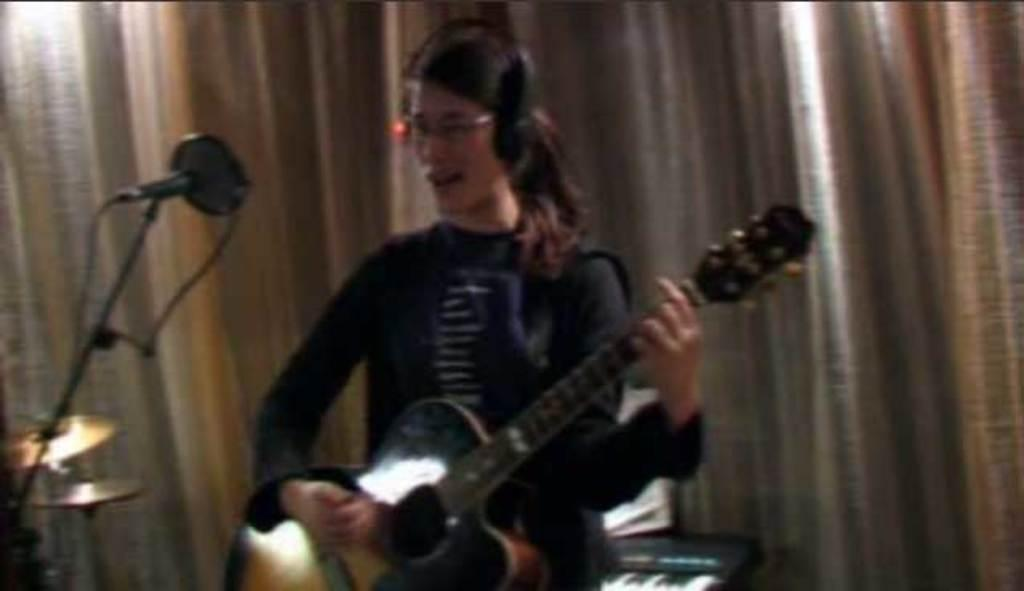Who is the main subject in the image? There is a lady in the picture. What is the lady doing in the image? The lady is sitting on a table. What is the lady wearing in the image? The lady is wearing a headset. What object is placed in front of the lady? There is a microphone placed in front of the lady. What can be seen in the background of the image? There is a curtain in the background of the image. What type of clam can be seen holding the rake in the image? There is no clam or rake present in the image. What route is the lady taking in the image? The image does not depict the lady taking any route; she is sitting on a table. 